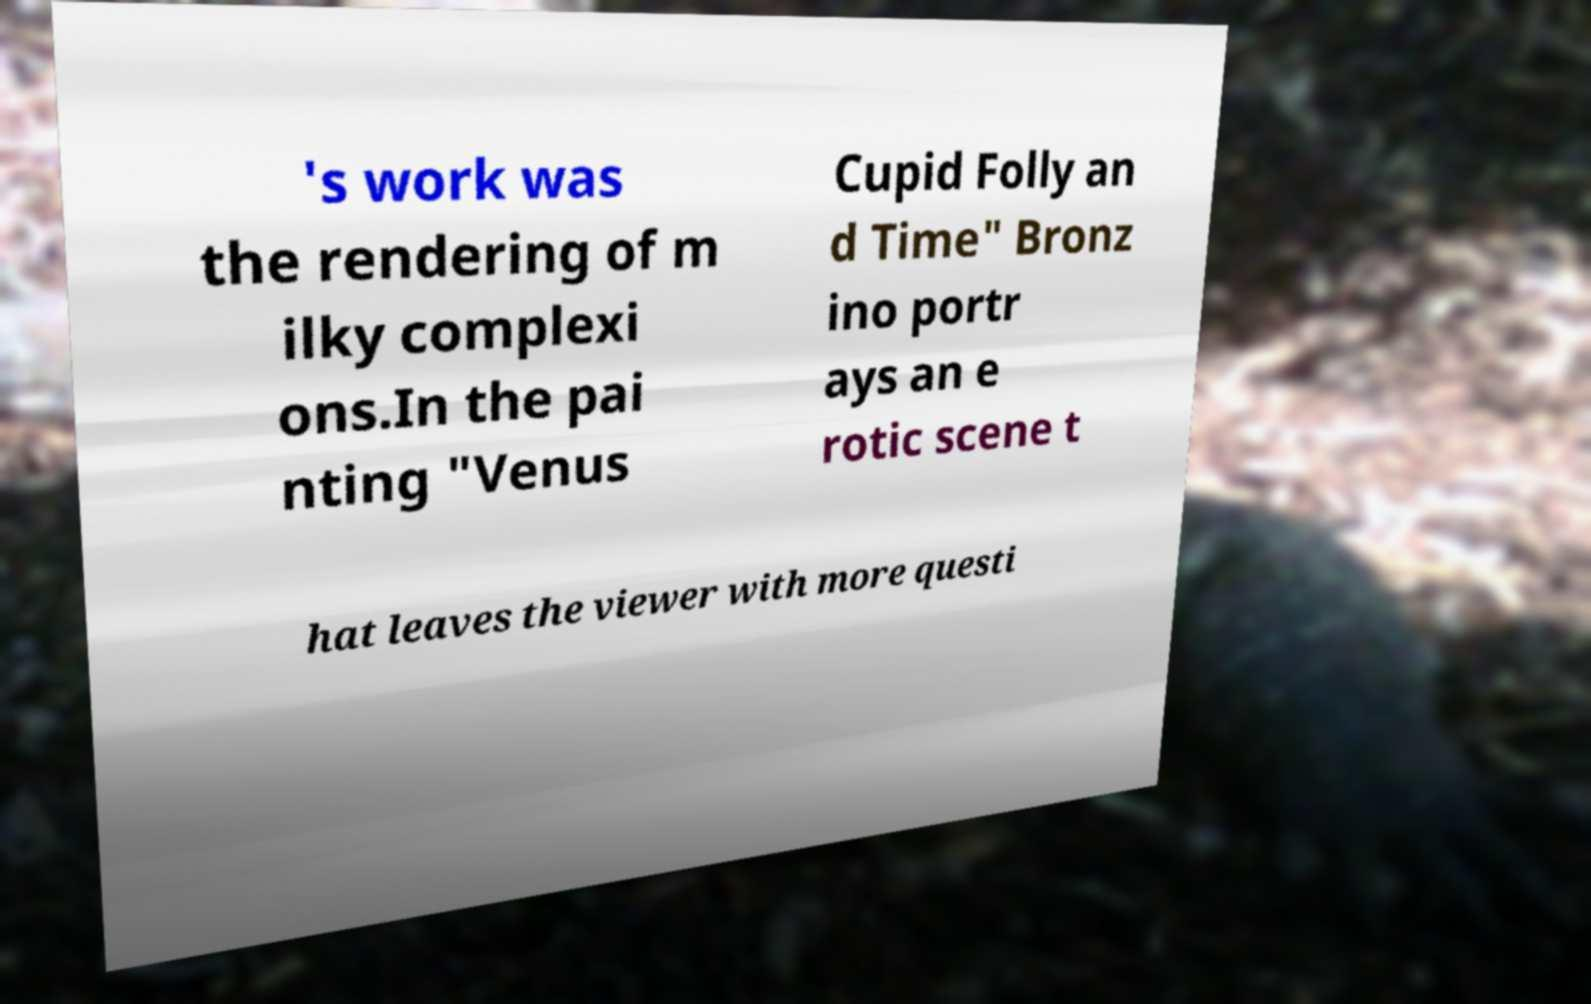Could you extract and type out the text from this image? 's work was the rendering of m ilky complexi ons.In the pai nting "Venus Cupid Folly an d Time" Bronz ino portr ays an e rotic scene t hat leaves the viewer with more questi 